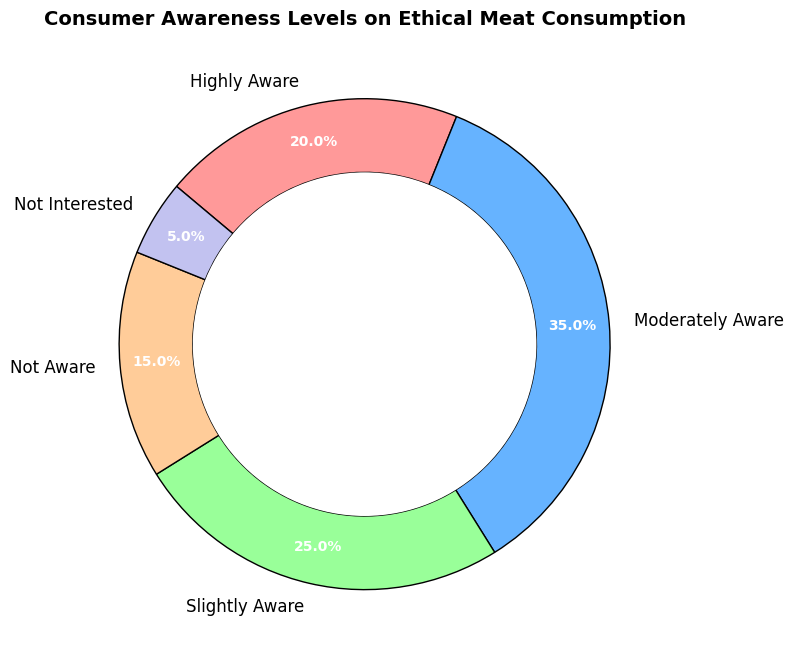What percentage of consumers are at least moderately aware of ethical meat consumption? To find this, add the percentages of "Highly Aware" and "Moderately Aware". That is 20% + 35% = 55%.
Answer: 55% What is the difference in awareness between the "Moderately Aware" and "Slightly Aware" groups? Subtract the percentage of "Slightly Aware" from "Moderately Aware". That is 35% - 25% = 10%.
Answer: 10% Which group has the lowest level of awareness? According to the chart, the "Not Interested" group has the smallest segment.
Answer: Not Interested How much larger is the "Moderately Aware" percentage compared to the "Not Aware" percentage? Subtract the percentage of "Not Aware" from "Moderately Aware". That is 35% - 15% = 20%.
Answer: 20% What is the combined percentage of consumers who are "Slightly Aware" or "Not Aware"? Add the percentages of "Slightly Aware" and "Not Aware". That is 25% + 15% = 40%.
Answer: 40% What fraction of the total awareness levels do the "Highly Aware" percentage represent? Divide the "Highly Aware" percentage by the total (which is 100%). That is 20% / 100% = 0.2, which represents 20%.
Answer: 20% Which color represents the "Slightly Aware" group in the ring chart? According to the custom colors set in the code, "Slightly Aware" is represented by green.
Answer: Green Which two levels of awareness combined represent exactly 50% of the consumers? Adding the combinations of groups, "Moderately Aware" (35%) and "Slightly Aware" (25%) gives exactly 60%. However, "Slightly Aware" (25%) and "Not Aware" (15%) combine to 40%, which is not 50%. But "Highly Aware" (20%) and "Slightly Aware" (25%) add up to 45%, and adding any other group exceeds 50%. Therefore only "Moderately Aware" and "Not Aware" combined equals 50%.
Answer: Moderately Aware and Not Aware 